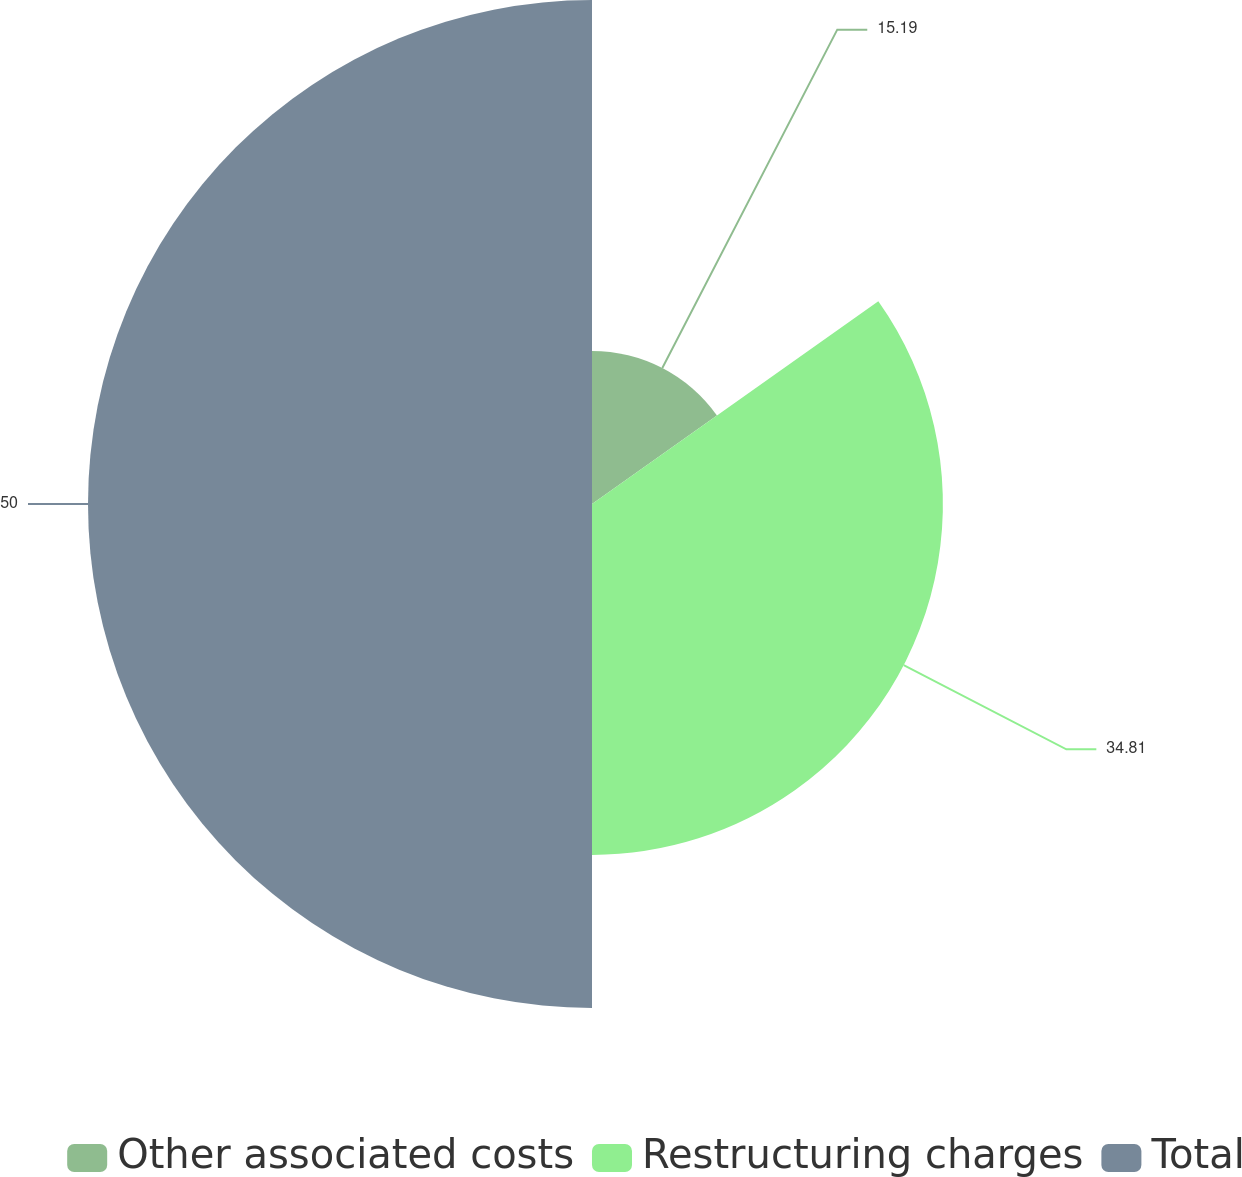Convert chart to OTSL. <chart><loc_0><loc_0><loc_500><loc_500><pie_chart><fcel>Other associated costs<fcel>Restructuring charges<fcel>Total<nl><fcel>15.19%<fcel>34.81%<fcel>50.0%<nl></chart> 